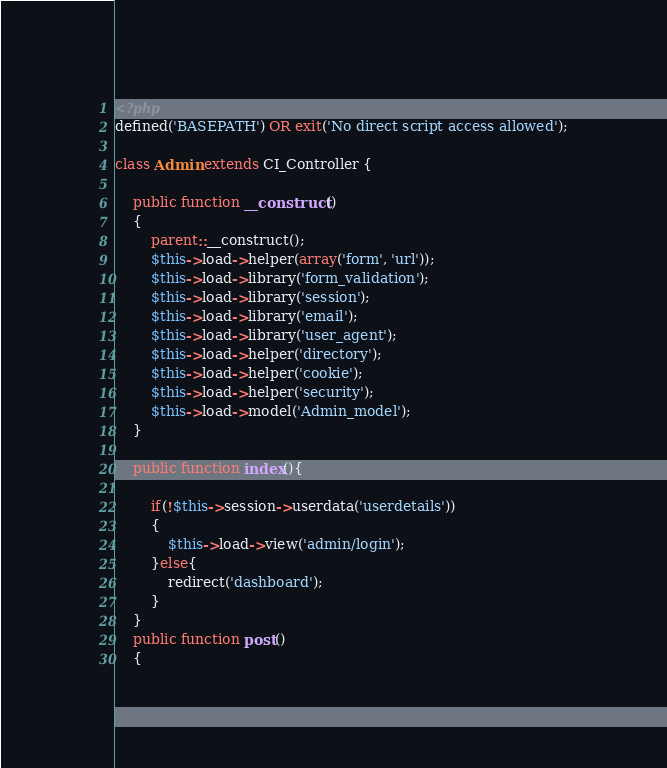<code> <loc_0><loc_0><loc_500><loc_500><_PHP_><?php
defined('BASEPATH') OR exit('No direct script access allowed');

class Admin extends CI_Controller {

	public function __construct() 
	{
		parent::__construct();	
		$this->load->helper(array('form', 'url'));
		$this->load->library('form_validation');
		$this->load->library('session');
		$this->load->library('email');
		$this->load->library('user_agent');
		$this->load->helper('directory');
		$this->load->helper('cookie');
		$this->load->helper('security');
		$this->load->model('Admin_model');
	}
	
	public function index(){
		
		if(!$this->session->userdata('userdetails'))
		{
			$this->load->view('admin/login');
		}else{
			redirect('dashboard');
		}
	}
	public function post()
	{</code> 